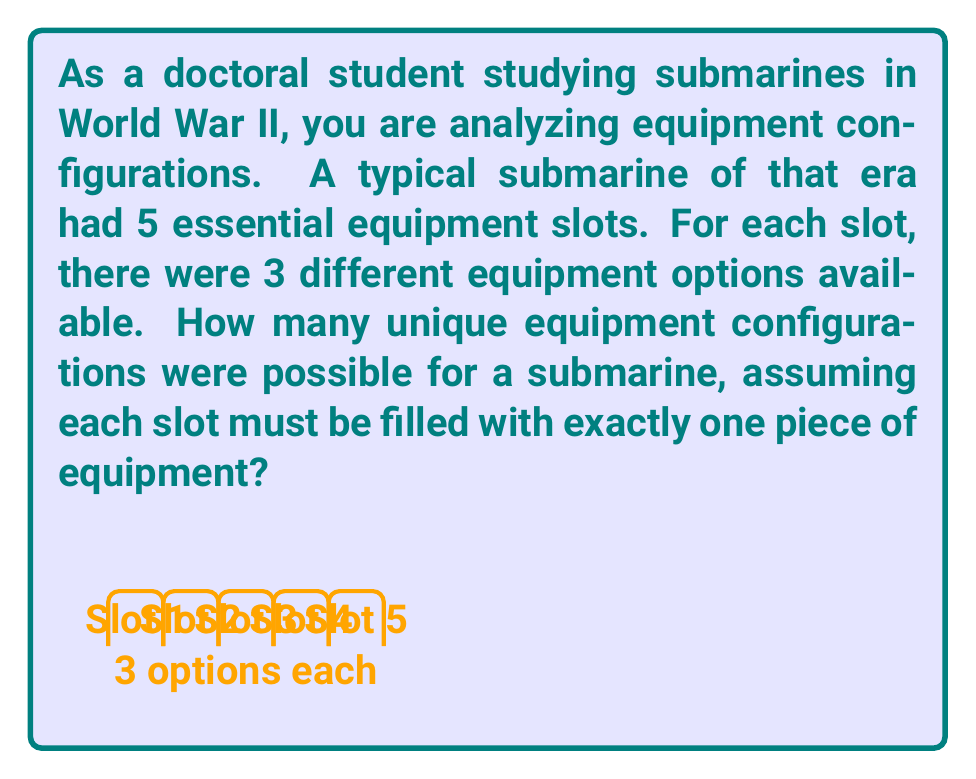Can you solve this math problem? Let's approach this step-by-step:

1) We have 5 equipment slots, and each slot has 3 options.

2) This is a perfect scenario for applying the multiplication principle of counting.

3) The multiplication principle states that if we have $n$ independent events, and each event $i$ has $m_i$ possible outcomes, then the total number of possible outcomes for all events is the product of the number of outcomes for each event.

4) In this case, we have 5 independent events (choosing equipment for each slot), and each event has 3 possible outcomes (3 equipment options).

5) Therefore, the total number of possible configurations is:

   $$ 3 \times 3 \times 3 \times 3 \times 3 = 3^5 $$

6) We can calculate this:

   $$ 3^5 = 3 \times 3 \times 3 \times 3 \times 3 = 243 $$

Thus, there are 243 possible unique equipment configurations for the submarine.
Answer: 243 